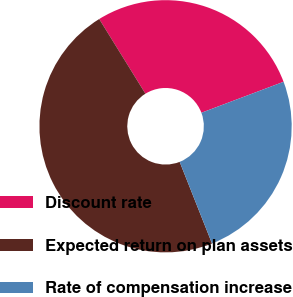Convert chart to OTSL. <chart><loc_0><loc_0><loc_500><loc_500><pie_chart><fcel>Discount rate<fcel>Expected return on plan assets<fcel>Rate of compensation increase<nl><fcel>28.08%<fcel>47.18%<fcel>24.73%<nl></chart> 